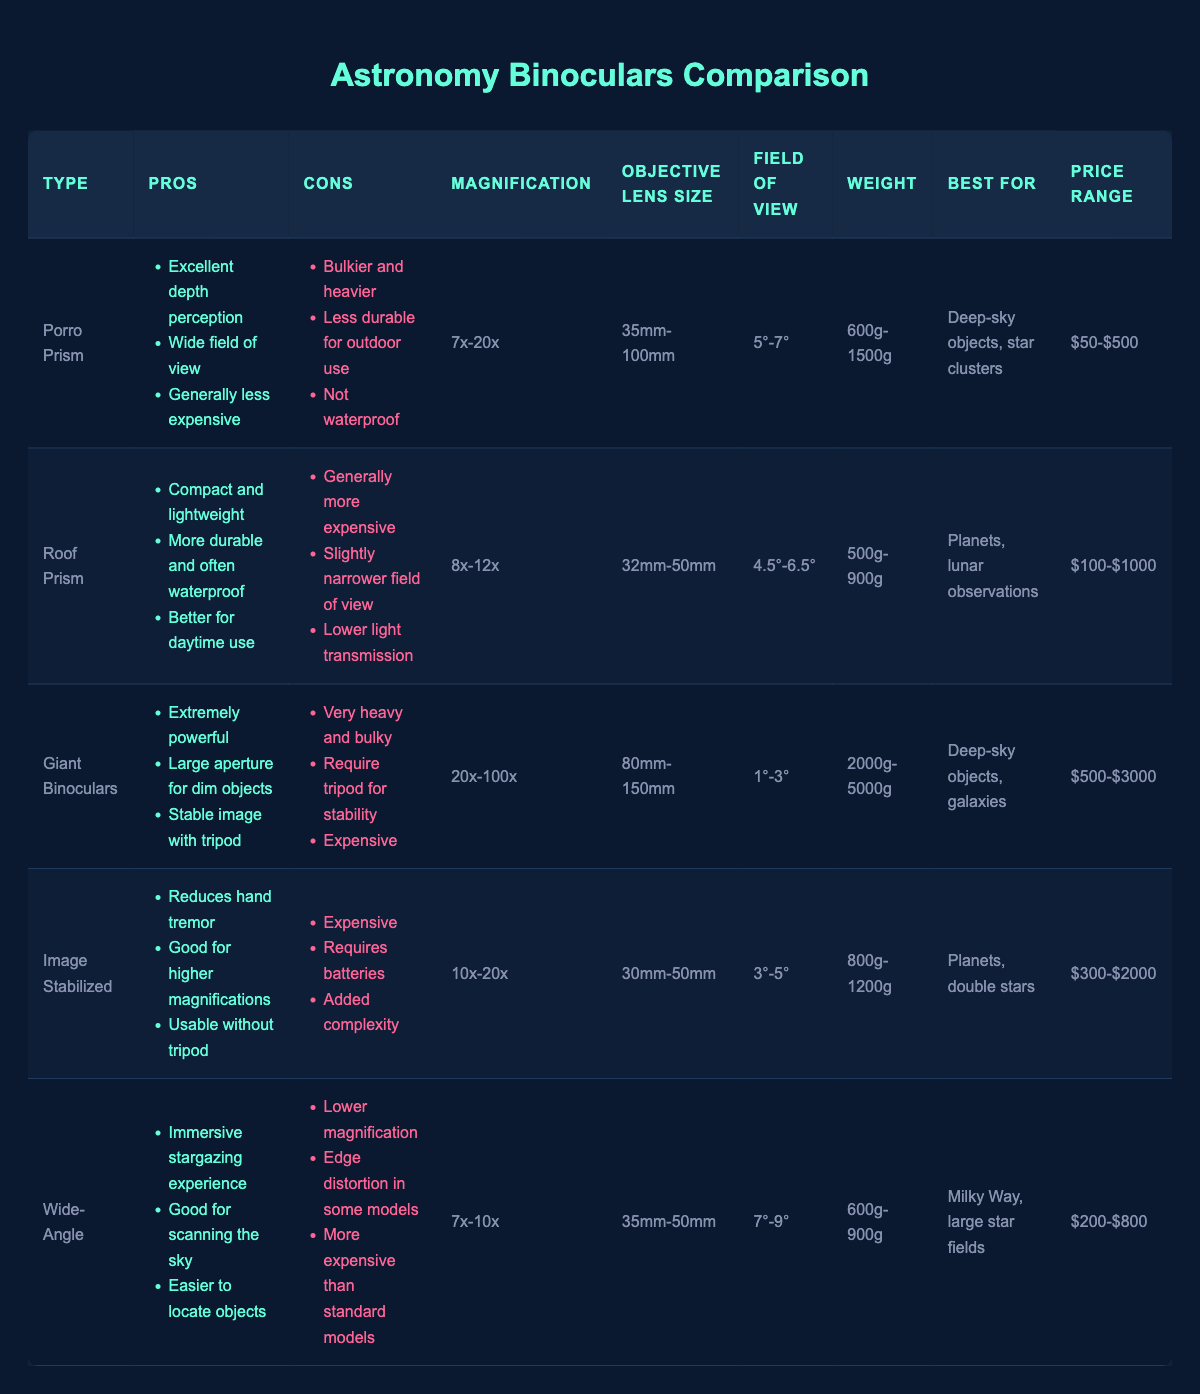What is the weight range of the Giant Binoculars? The weight range for the Giant Binoculars is listed in the table, and it shows 2000g to 5000g.
Answer: 2000g-5000g Which type of binoculars is best for viewing deep-sky objects? Looking at the "Best For" column, the Porro Prism and Giant Binoculars are both listed for deep-sky objects. However, Giant Binoculars are noted for their extremely powerful magnification and large aperture, making them superior for dim objects.
Answer: Giant Binoculars Are Roof Prism binoculars waterproof? In the "Cons" column for Roof Prism binoculars, it states that they are more durable and often waterproof, indicating that they are typically waterproof.
Answer: Yes What is the average magnification of Wide-Angle binoculars and Image Stabilized binoculars combined? The magnification for Wide-Angle binoculars is from 7x to 10x, which averages to 8.5x, while Image Stabilized binoculars have a range of 10x to 20x, averaging to 15x. So, combining both averages, we have (8.5 + 15) / 2 = 11.75.
Answer: 11.75x Which type of binoculars has the widest field of view? The "Field of View" column shows that the Wide-Angle binoculars have a range of 7° to 9°, which is wider than the other types.
Answer: Wide-Angle What characteristics make Image Stabilized binoculars unique compared to other types? Image Stabilized binoculars have the unique pros of reducing hand tremor and usability without a tripod. These advantages make them appealing for specific high-magnification needs while also requiring batteries and being expensive.
Answer: Reduces hand tremor, usable without tripod Is it true that Giant Binoculars require a tripod for stability? The "Cons" for Giant Binoculars indicate that they require a tripod for stability, confirming this is true.
Answer: Yes What is the price range of the least expensive binocular type? In the "Price Range" column, the Porro Prism binoculars have the least expensive range, starting from $50 to $500.
Answer: $50-$500 